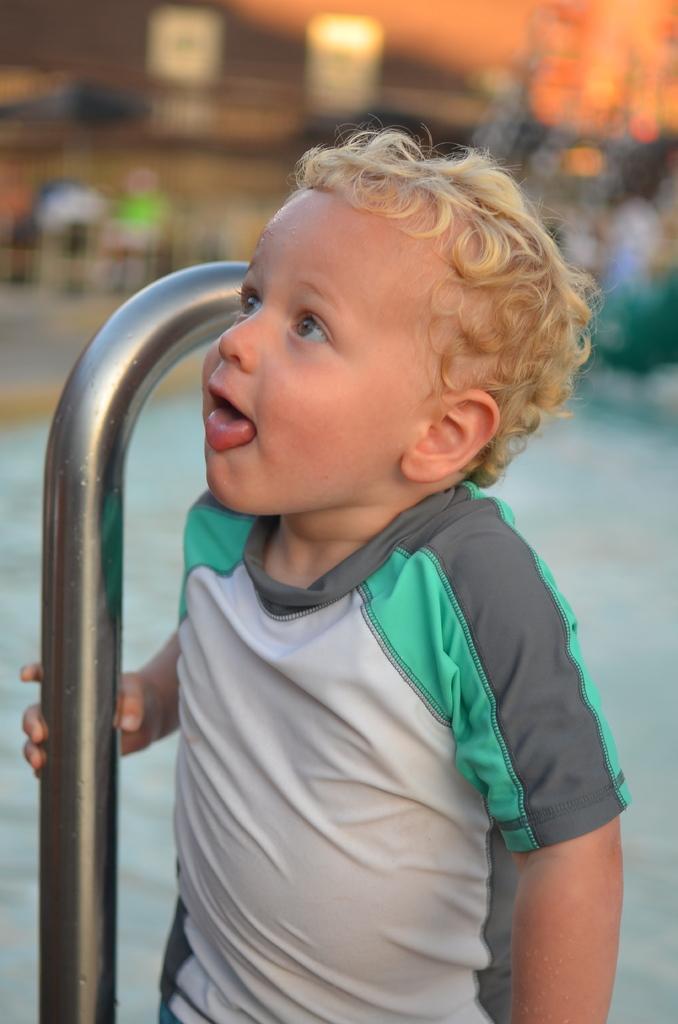Could you give a brief overview of what you see in this image? This picture shows a boy standing and holding a metal rod and we see water on the back. 